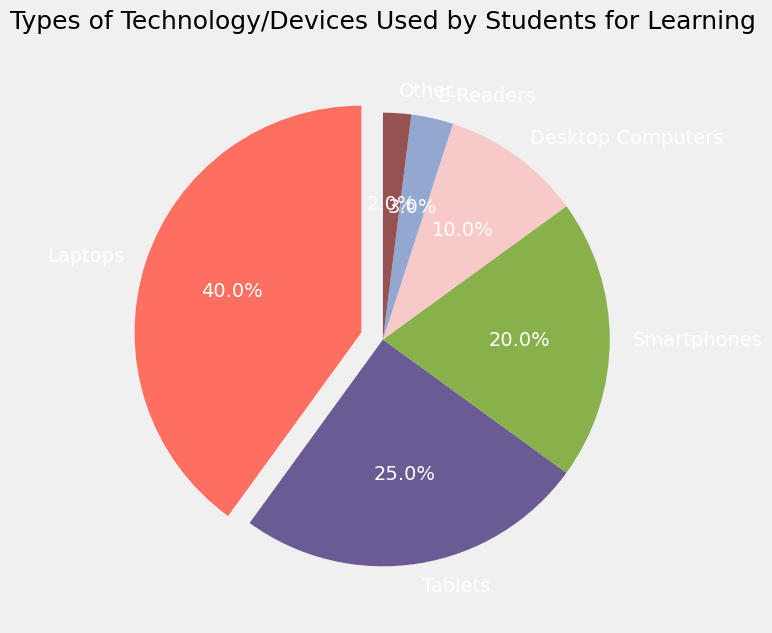What percentage of students use laptops for learning? The pie chart shows the percentage of students using each type of technology/device. The sector labeled "Laptops" shows a percentage value.
Answer: 40% Which device is used by the least number of students? To find the device used by the least number of students, look at the smallest sector in the pie chart. The "Other" category has the smallest percentage value.
Answer: Other What is the combined percentage of students using tablets and smartphones? Add the percentages for "Tablets" and "Smartphones", which are 25% and 20%, respectively. The sum is 25% + 20% = 45%.
Answer: 45% How does the usage of desktop computers compare to e-readers? Compare the percentages of "Desktop Computers" and "E-Readers". Desktop computers have a higher percentage (10%) compared to e-readers (3%).
Answer: Desktop Computers > E-Readers What is the difference between the highest and the lowest percentage of device usage? Find the difference between the highest percentage (laptops: 40%) and the lowest percentage (other: 2%). The difference is 40% - 2% = 38%.
Answer: 38% What device is represented by the most visually emphasized sector and why? Identify the sector that is visually emphasized by being "exploded" or separated slightly from the pie chart. The "Laptops" sector is exploded because it has the largest percentage.
Answer: Laptops How many more percentage points do students use smartphones compared to e-readers? Subtract the percentage of e-readers (3%) from the percentage of smartphones (20%). The difference is 20% - 3% = 17%.
Answer: 17% What is the total percentage of students using devices other than laptops? Find the sum of the percentages of all devices other than laptops: Tablets (25%) + Smartphones (20%) + Desktop Computers (10%) + E-Readers (3%) + Other (2%) = 60%.
Answer: 60% Which color represents tablets in the pie chart? Visually match the label "Tablets" to its corresponding sector's color in the pie chart. Tablets are represented by the color purple.
Answer: Purple 